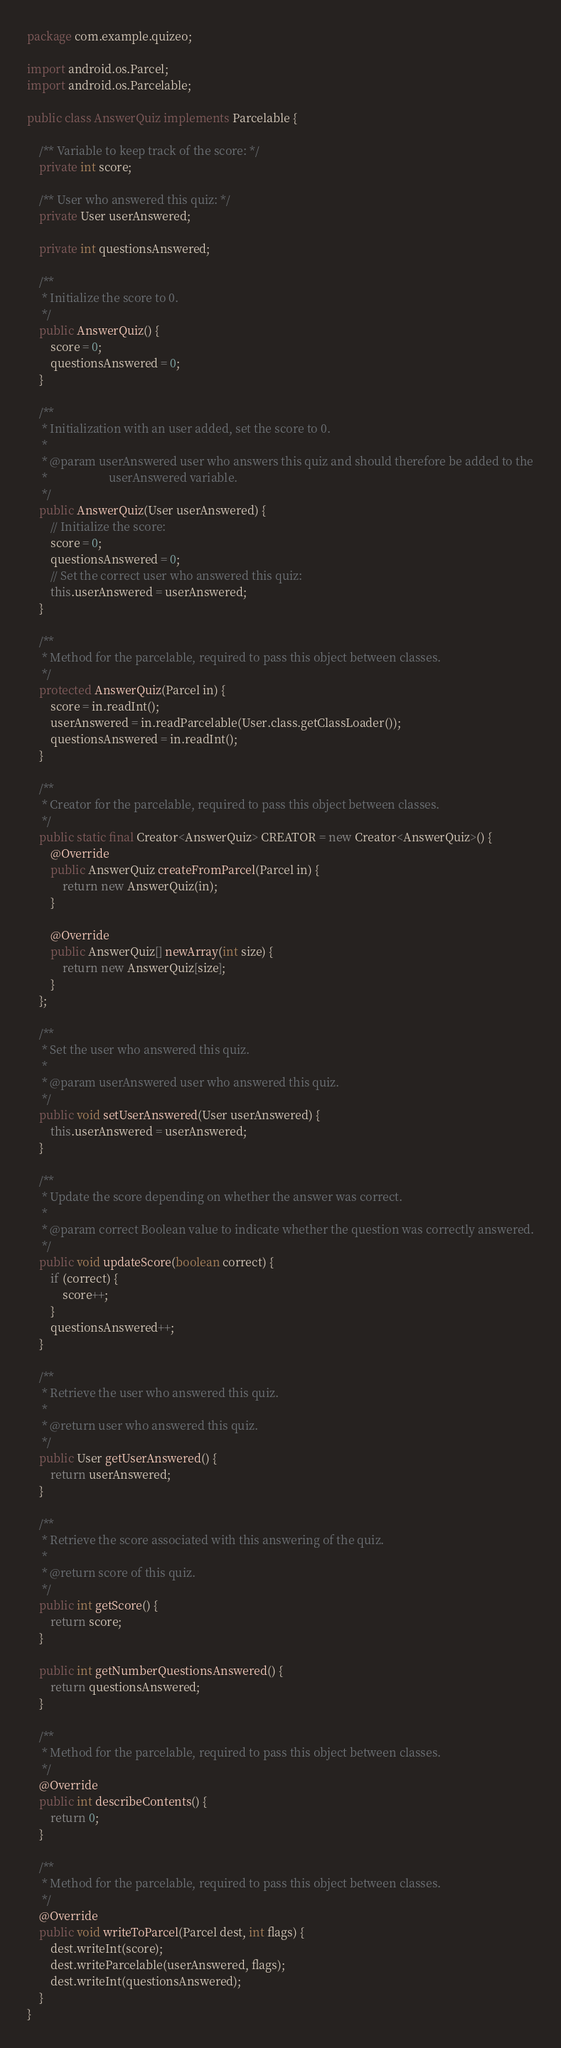<code> <loc_0><loc_0><loc_500><loc_500><_Java_>package com.example.quizeo;

import android.os.Parcel;
import android.os.Parcelable;

public class AnswerQuiz implements Parcelable {

    /** Variable to keep track of the score: */
    private int score;

    /** User who answered this quiz: */
    private User userAnswered;

    private int questionsAnswered;

    /**
     * Initialize the score to 0.
     */
    public AnswerQuiz() {
        score = 0;
        questionsAnswered = 0;
    }

    /**
     * Initialization with an user added, set the score to 0.
     *
     * @param userAnswered user who answers this quiz and should therefore be added to the
     *                     userAnswered variable.
     */
    public AnswerQuiz(User userAnswered) {
        // Initialize the score:
        score = 0;
        questionsAnswered = 0;
        // Set the correct user who answered this quiz:
        this.userAnswered = userAnswered;
    }

    /**
     * Method for the parcelable, required to pass this object between classes.
     */
    protected AnswerQuiz(Parcel in) {
        score = in.readInt();
        userAnswered = in.readParcelable(User.class.getClassLoader());
        questionsAnswered = in.readInt();
    }

    /**
     * Creator for the parcelable, required to pass this object between classes.
     */
    public static final Creator<AnswerQuiz> CREATOR = new Creator<AnswerQuiz>() {
        @Override
        public AnswerQuiz createFromParcel(Parcel in) {
            return new AnswerQuiz(in);
        }

        @Override
        public AnswerQuiz[] newArray(int size) {
            return new AnswerQuiz[size];
        }
    };

    /**
     * Set the user who answered this quiz.
     *
     * @param userAnswered user who answered this quiz.
     */
    public void setUserAnswered(User userAnswered) {
        this.userAnswered = userAnswered;
    }

    /**
     * Update the score depending on whether the answer was correct.
     *
     * @param correct Boolean value to indicate whether the question was correctly answered.
     */
    public void updateScore(boolean correct) {
        if (correct) {
            score++;
        }
        questionsAnswered++;
    }

    /**
     * Retrieve the user who answered this quiz.
     *
     * @return user who answered this quiz.
     */
    public User getUserAnswered() {
        return userAnswered;
    }

    /**
     * Retrieve the score associated with this answering of the quiz.
     *
     * @return score of this quiz.
     */
    public int getScore() {
        return score;
    }

    public int getNumberQuestionsAnswered() {
        return questionsAnswered;
    }

    /**
     * Method for the parcelable, required to pass this object between classes.
     */
    @Override
    public int describeContents() {
        return 0;
    }

    /**
     * Method for the parcelable, required to pass this object between classes.
     */
    @Override
    public void writeToParcel(Parcel dest, int flags) {
        dest.writeInt(score);
        dest.writeParcelable(userAnswered, flags);
        dest.writeInt(questionsAnswered);
    }
}


</code> 